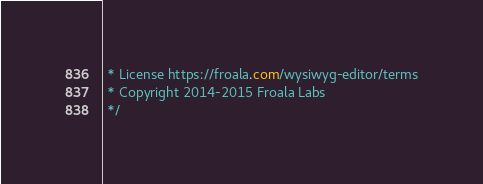Convert code to text. <code><loc_0><loc_0><loc_500><loc_500><_CSS_> * License https://froala.com/wysiwyg-editor/terms
 * Copyright 2014-2015 Froala Labs
 */
</code> 